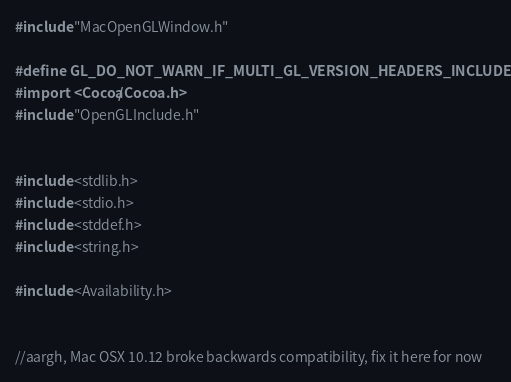Convert code to text. <code><loc_0><loc_0><loc_500><loc_500><_ObjectiveC_>#include "MacOpenGLWindow.h"

#define GL_DO_NOT_WARN_IF_MULTI_GL_VERSION_HEADERS_INCLUDED
#import <Cocoa/Cocoa.h>
#include "OpenGLInclude.h"


#include <stdlib.h>
#include <stdio.h>
#include <stddef.h>
#include <string.h>

#include <Availability.h>


//aargh, Mac OSX 10.12 broke backwards compatibility, fix it here for now</code> 